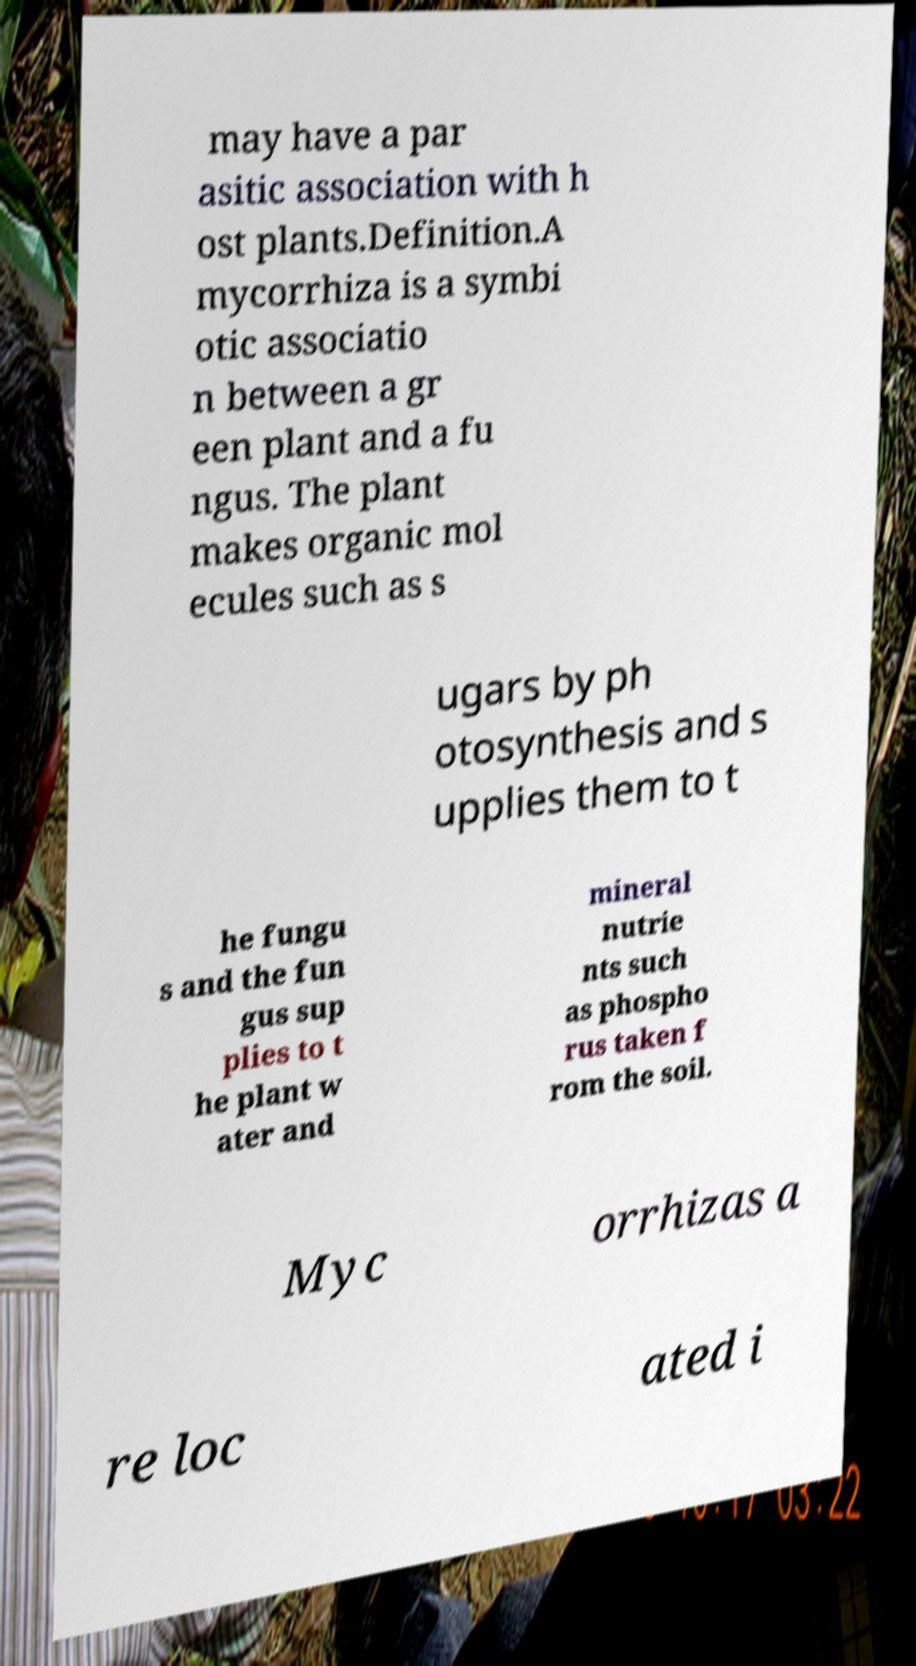Please identify and transcribe the text found in this image. may have a par asitic association with h ost plants.Definition.A mycorrhiza is a symbi otic associatio n between a gr een plant and a fu ngus. The plant makes organic mol ecules such as s ugars by ph otosynthesis and s upplies them to t he fungu s and the fun gus sup plies to t he plant w ater and mineral nutrie nts such as phospho rus taken f rom the soil. Myc orrhizas a re loc ated i 